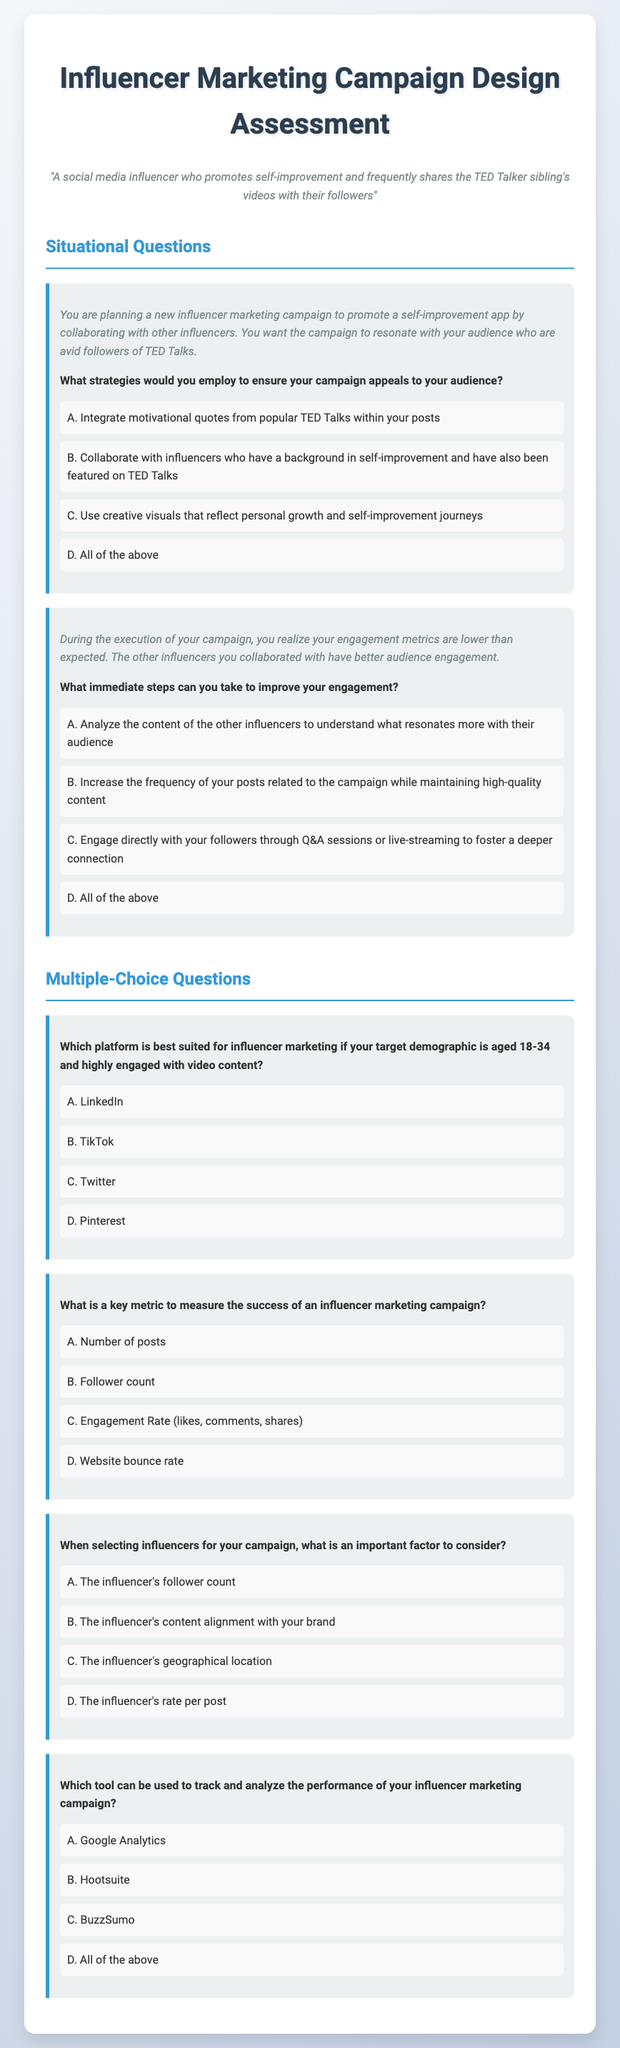What is the title of the document? The title is specified in the <title> tag of the document.
Answer: Influencer Marketing Campaign Design Assessment What is the persona described in the document? The persona is mentioned prominently at the beginning of the document.
Answer: A social media influencer who promotes self-improvement and frequently shares the TED Talker sibling's videos with their followers How many situational questions are in the document? The document lists two sections: Situational Questions and Multiple-Choice Questions. The situation section has two questions.
Answer: 2 What is an engagement metric mentioned in the situational questions? The document discusses engagement metrics related to campaign performance in one of the situational questions.
Answer: Engagement Rate Which social media platform is best suited for the target demographic aged 18-34? An option is clearly defined in the multiple-choice questions referring to the appropriate platform for a specific age group.
Answer: TikTok What is a key factor to consider when selecting influencers? The document suggests one important aspect to consider in the selection process.
Answer: The influencer's content alignment with your brand Which tool is mentioned to track the performance of the campaign? The document lists tools for analyzing campaign performance under the multiple-choice questions section.
Answer: Google Analytics Which option is recommended to improve engagement during the campaign? The document provides a collective strategy in the situational questions for improving engagement metrics.
Answer: All of the above 